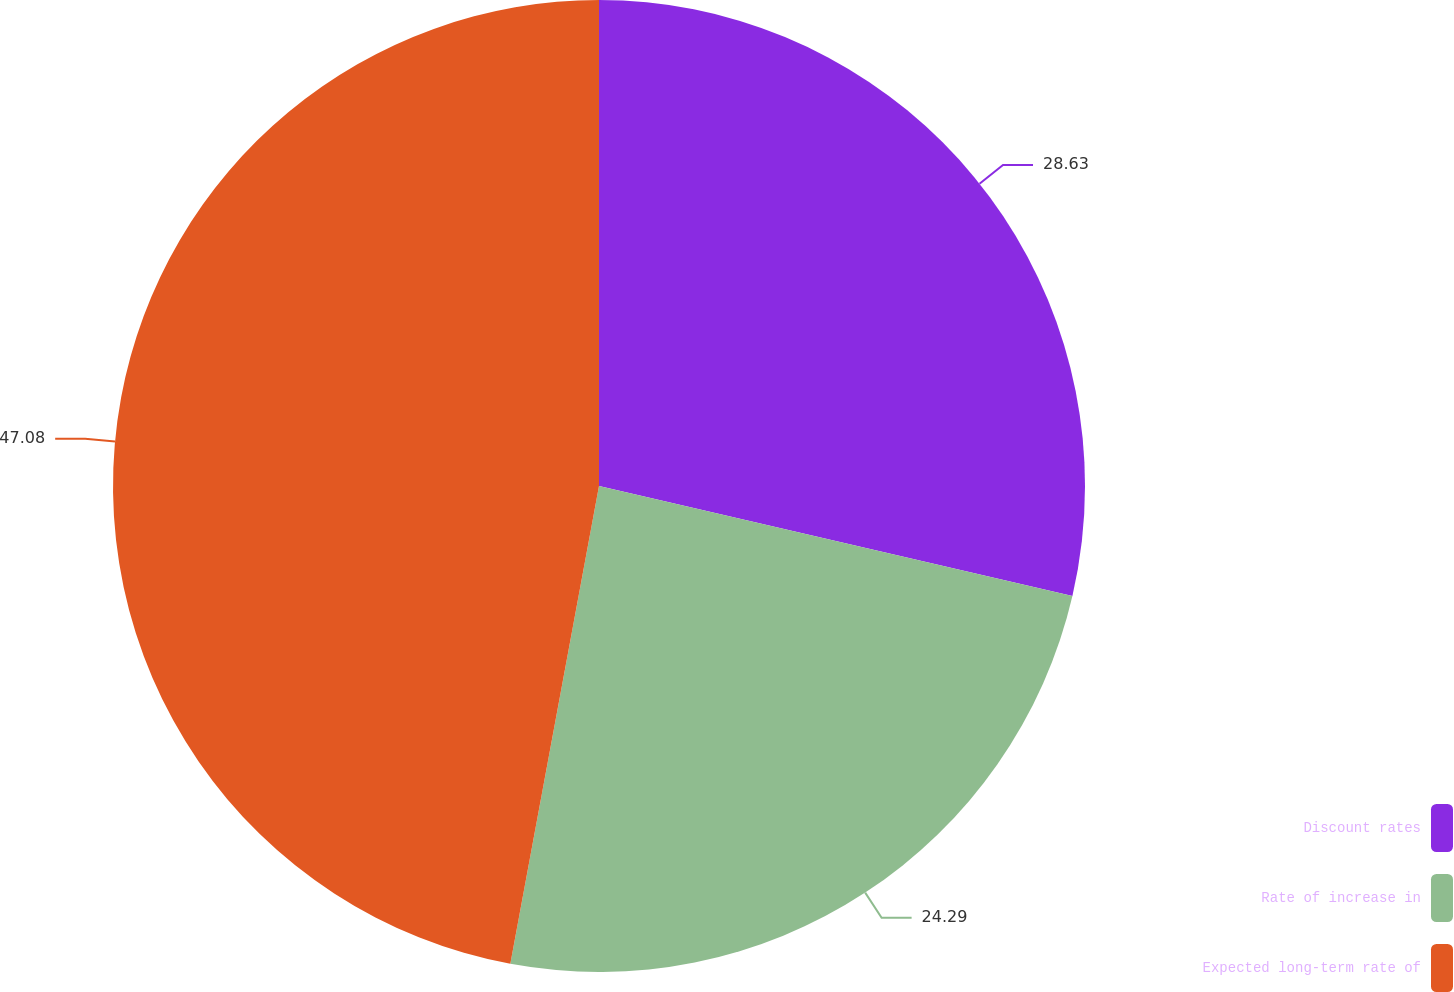<chart> <loc_0><loc_0><loc_500><loc_500><pie_chart><fcel>Discount rates<fcel>Rate of increase in<fcel>Expected long-term rate of<nl><fcel>28.63%<fcel>24.29%<fcel>47.08%<nl></chart> 